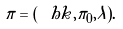Convert formula to latex. <formula><loc_0><loc_0><loc_500><loc_500>\sl { \pi } = ( \sl { \ h k } , \sl { \pi _ { 0 } } , \lambda ) .</formula> 